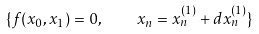<formula> <loc_0><loc_0><loc_500><loc_500>\{ f ( x _ { 0 } , x _ { 1 } ) = 0 , \quad x _ { n } = x _ { n } ^ { ( 1 ) } + d x _ { n } ^ { ( 1 ) } \}</formula> 